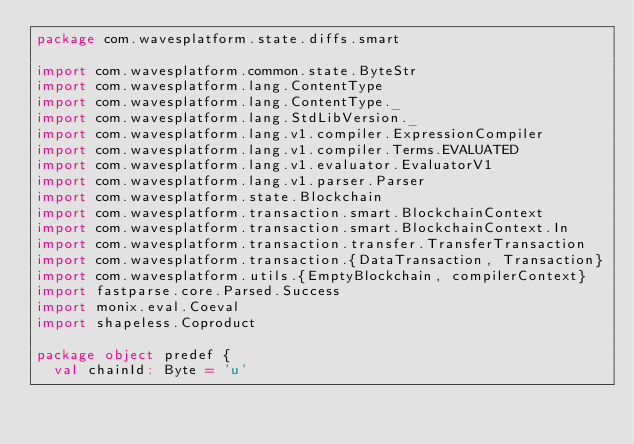Convert code to text. <code><loc_0><loc_0><loc_500><loc_500><_Scala_>package com.wavesplatform.state.diffs.smart

import com.wavesplatform.common.state.ByteStr
import com.wavesplatform.lang.ContentType
import com.wavesplatform.lang.ContentType._
import com.wavesplatform.lang.StdLibVersion._
import com.wavesplatform.lang.v1.compiler.ExpressionCompiler
import com.wavesplatform.lang.v1.compiler.Terms.EVALUATED
import com.wavesplatform.lang.v1.evaluator.EvaluatorV1
import com.wavesplatform.lang.v1.parser.Parser
import com.wavesplatform.state.Blockchain
import com.wavesplatform.transaction.smart.BlockchainContext
import com.wavesplatform.transaction.smart.BlockchainContext.In
import com.wavesplatform.transaction.transfer.TransferTransaction
import com.wavesplatform.transaction.{DataTransaction, Transaction}
import com.wavesplatform.utils.{EmptyBlockchain, compilerContext}
import fastparse.core.Parsed.Success
import monix.eval.Coeval
import shapeless.Coproduct

package object predef {
  val chainId: Byte = 'u'
</code> 